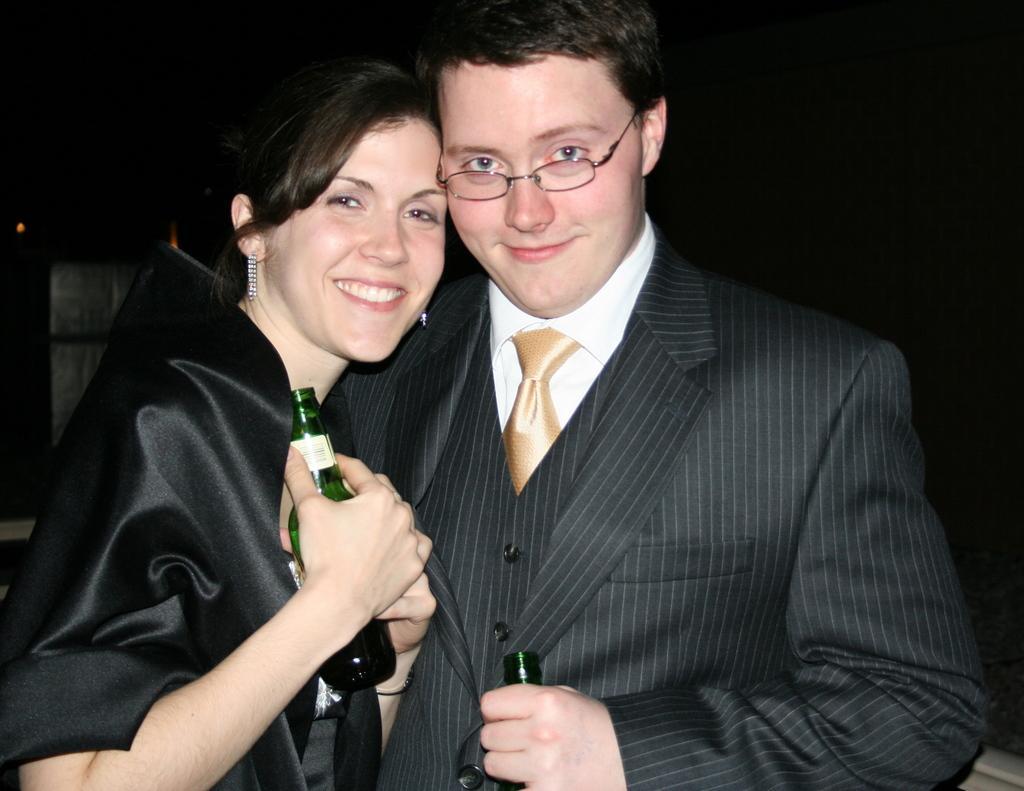Describe this image in one or two sentences. In this image, women and men are in black color dress. They both are hold a bottle on his hands. Men wear a glasses. 